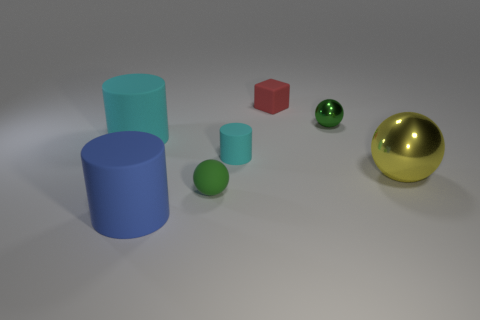Add 1 matte spheres. How many objects exist? 8 Subtract all blocks. How many objects are left? 6 Subtract 0 purple cubes. How many objects are left? 7 Subtract all big brown metallic cylinders. Subtract all blocks. How many objects are left? 6 Add 1 small cyan cylinders. How many small cyan cylinders are left? 2 Add 3 small red cylinders. How many small red cylinders exist? 3 